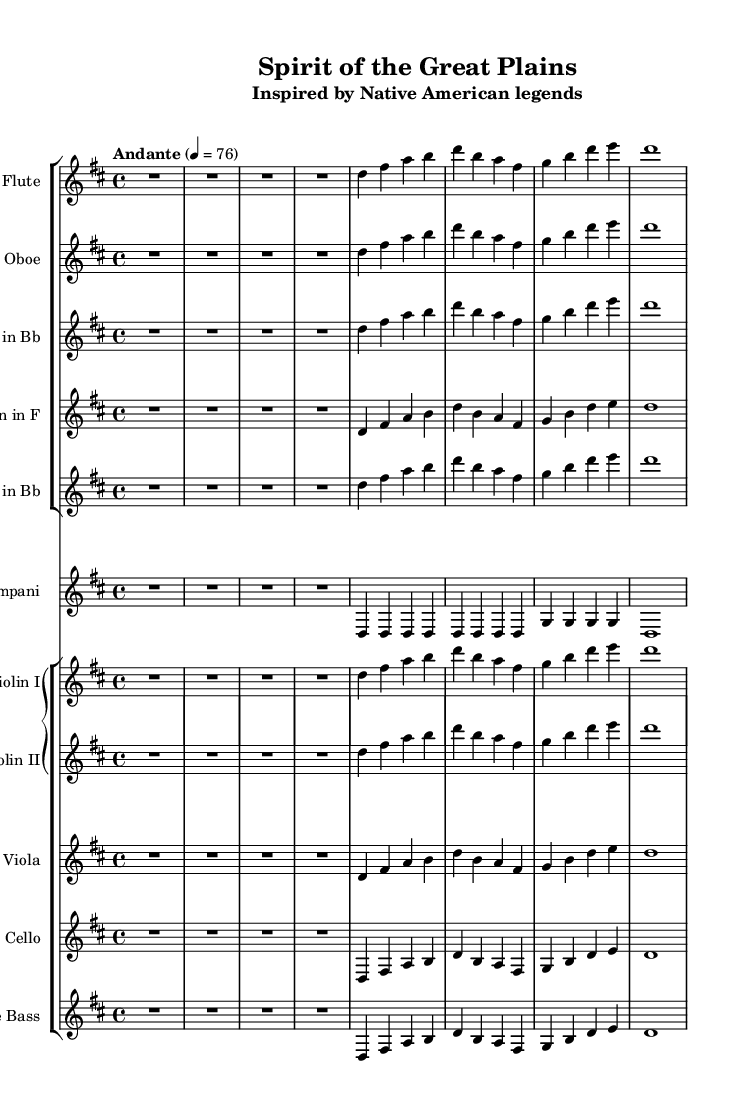What is the key signature of this music? The key signature is indicated by the number of sharps or flats at the beginning of the staff. Here, there are two sharps (F# and C#), which is characteristic of the key of D major.
Answer: D major What is the time signature of this music? The time signature is found at the beginning of the staff and shows the rhythm of the piece. The "4/4" indicates that there are four beats in each measure and the quarter note gets one beat.
Answer: 4/4 What is the tempo marking of this piece? The tempo marking is located above the staff and reads "Andante" with a metronome marking of 76. This indicates a slow, walking pace for the performance.
Answer: Andante, 76 Which instruments are part of the woodwind section in this piece? The woodwind instruments are identified by their respective staffs. Flute, Oboe, Clarinet in Bb, and Horn in F are included in this section.
Answer: Flute, Oboe, Clarinet in Bb, Horn in F How many violin parts are included in this orchestration? The score displays the number of staves assigned to a particular instrument. There are two violin parts labeled Violin I and Violin II, indicating that both are included in the orchestration.
Answer: Two What is the theme of this orchestral piece? The title and subtitle of the piece, "Spirit of the Great Plains" and "Inspired by Native American legends", suggest that the theme revolves around Native American culture and its natural landscapes.
Answer: Native American legends Which rhythm value is predominantly used in the flute melody? The melody notes are analyzed for their rhythmic values. The flute melody primarily features quarter notes, as evidenced by the notation of the notes in the measures.
Answer: Quarter notes 